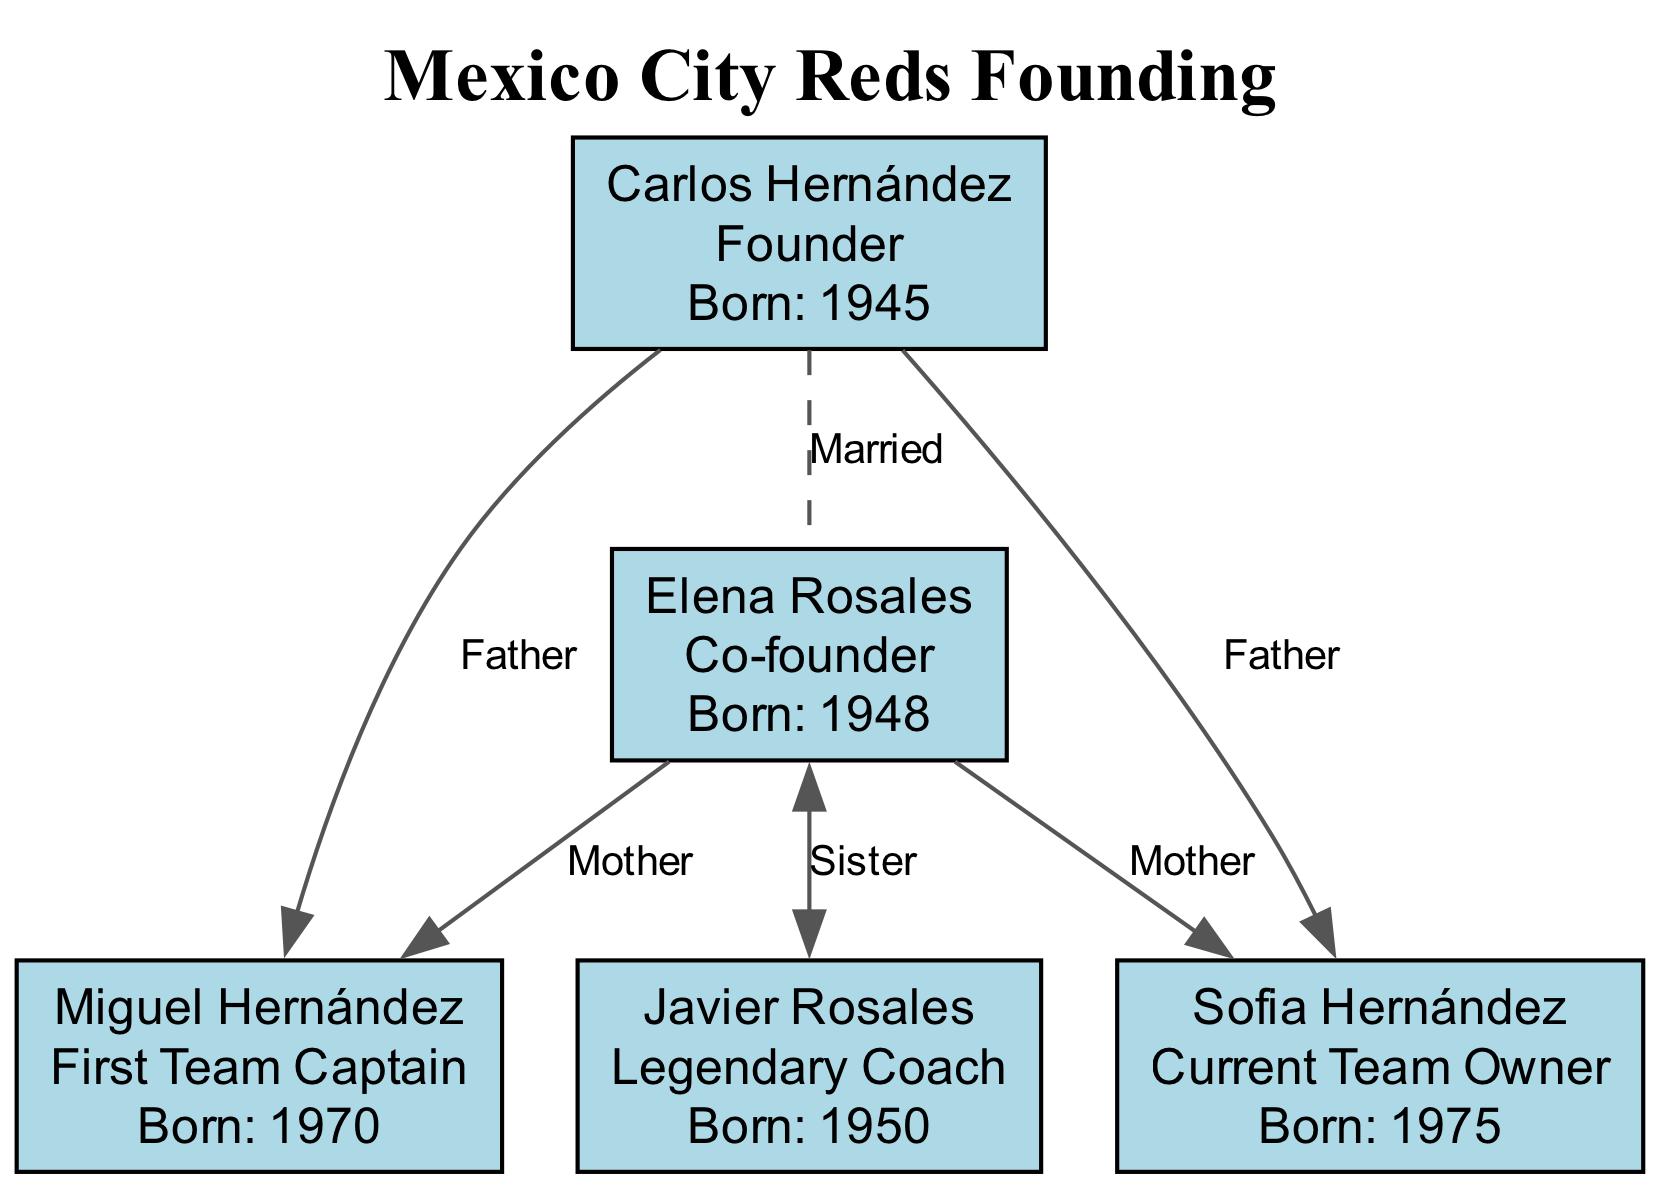What year was Carlos Hernández born? According to the diagram, the birth year for Carlos Hernández is directly indicated as 1945.
Answer: 1945 Who is the co-founder of the Mexico City Reds? The diagram specifies that Elena Rosales holds the role of Co-founder.
Answer: Elena Rosales How many children did Carlos Hernández have? By reviewing the diagram, Carlos Hernández has two children listed: Miguel Hernández and Sofia Hernández, counted directly from the relationships shown.
Answer: 2 What role does Sofia Hernández currently hold? The diagram explicitly states that Sofia Hernández is the Current Team Owner.
Answer: Current Team Owner Who is the sister of Elena Rosales? As per the relationships in the diagram, Elena Rosales has a sister named Javier Rosales.
Answer: Javier Rosales What is the relationship between Miguel Hernández and Carlos Hernández? The diagram illustrates that Miguel Hernández is the son of Carlos Hernández, identified by the relationship labeled as "Father."
Answer: Father Who is the first team captain of the Mexico City Reds? The diagram directly provides the information that the first team captain is Miguel Hernández.
Answer: Miguel Hernández Which founding member is also a legendary coach? The diagram states that Javier Rosales is referred to as the Legendary Coach, indicating his connection to the founding members.
Answer: Javier Rosales What is the role of Elena Rosales? According to the diagram, Elena Rosales is identified as a Co-founder of the team.
Answer: Co-founder 